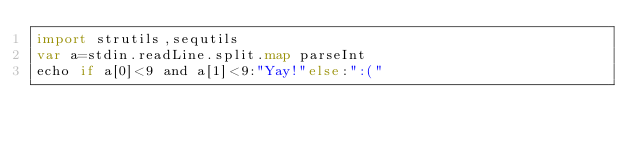Convert code to text. <code><loc_0><loc_0><loc_500><loc_500><_Nim_>import strutils,sequtils
var a=stdin.readLine.split.map parseInt
echo if a[0]<9 and a[1]<9:"Yay!"else:":("</code> 